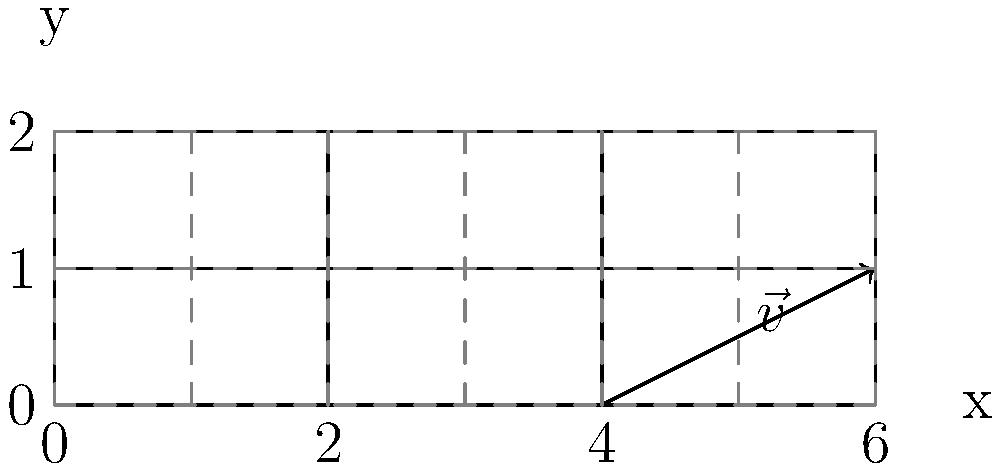In a modular construction system for disaster-resistant housing, identical units are arranged in a grid pattern as shown. If the translation vector $\vec{v}$ represents the shift from one module to another, what is the mathematical expression for the position of any module $(m,n)$ in terms of the base module position $(x_0, y_0)$ and the components of $\vec{v} = (v_x, v_y)$? To solve this problem, we need to understand how translational symmetry works in a grid pattern:

1. Observe that each module is a translated version of the base module.
2. The translation vector $\vec{v}$ represents the shift from one module to the next in the diagonal direction.
3. We can decompose this translation into horizontal and vertical components:
   - Horizontal component: $v_x = 2$ units
   - Vertical component: $v_y = 1$ unit

4. For any module $(m,n)$ in the grid:
   - It is shifted $m$ times horizontally and $n$ times vertically from the base module.
   - The horizontal shift is $m \cdot v_x$
   - The vertical shift is $n \cdot v_y$

5. If the base module's position is $(x_0, y_0)$, then the position of module $(m,n)$ is:
   - x-coordinate: $x_0 + m \cdot v_x$
   - y-coordinate: $y_0 + n \cdot v_y$

6. Combining these, we get the vector equation:
   $$(x, y) = (x_0, y_0) + m(v_x, 0) + n(0, v_y)$$

7. Which simplifies to:
   $$(x, y) = (x_0 + mv_x, y_0 + nv_y)$$

This equation represents the position of any module $(m,n)$ in terms of the base module position and the components of the translation vector.
Answer: $$(x, y) = (x_0 + mv_x, y_0 + nv_y)$$ 